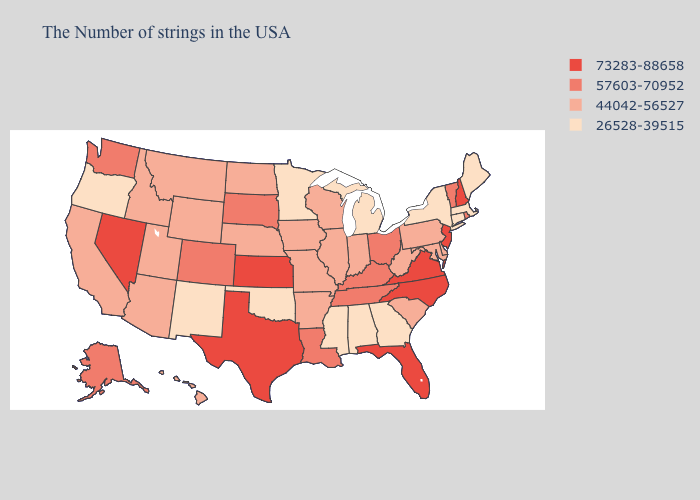Does Washington have a higher value than Alaska?
Be succinct. No. What is the lowest value in the USA?
Be succinct. 26528-39515. Does Idaho have the lowest value in the USA?
Short answer required. No. Name the states that have a value in the range 57603-70952?
Concise answer only. Rhode Island, Vermont, Ohio, Kentucky, Tennessee, Louisiana, South Dakota, Colorado, Washington, Alaska. What is the value of Oregon?
Concise answer only. 26528-39515. Does Pennsylvania have the lowest value in the Northeast?
Write a very short answer. No. What is the value of Montana?
Be succinct. 44042-56527. Among the states that border Missouri , which have the highest value?
Keep it brief. Kansas. What is the lowest value in states that border Mississippi?
Concise answer only. 26528-39515. Does the first symbol in the legend represent the smallest category?
Give a very brief answer. No. What is the value of Pennsylvania?
Answer briefly. 44042-56527. Does the map have missing data?
Quick response, please. No. Does the map have missing data?
Write a very short answer. No. Name the states that have a value in the range 73283-88658?
Short answer required. New Hampshire, New Jersey, Virginia, North Carolina, Florida, Kansas, Texas, Nevada. 